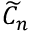Convert formula to latex. <formula><loc_0><loc_0><loc_500><loc_500>{ \widetilde { C } } _ { n }</formula> 